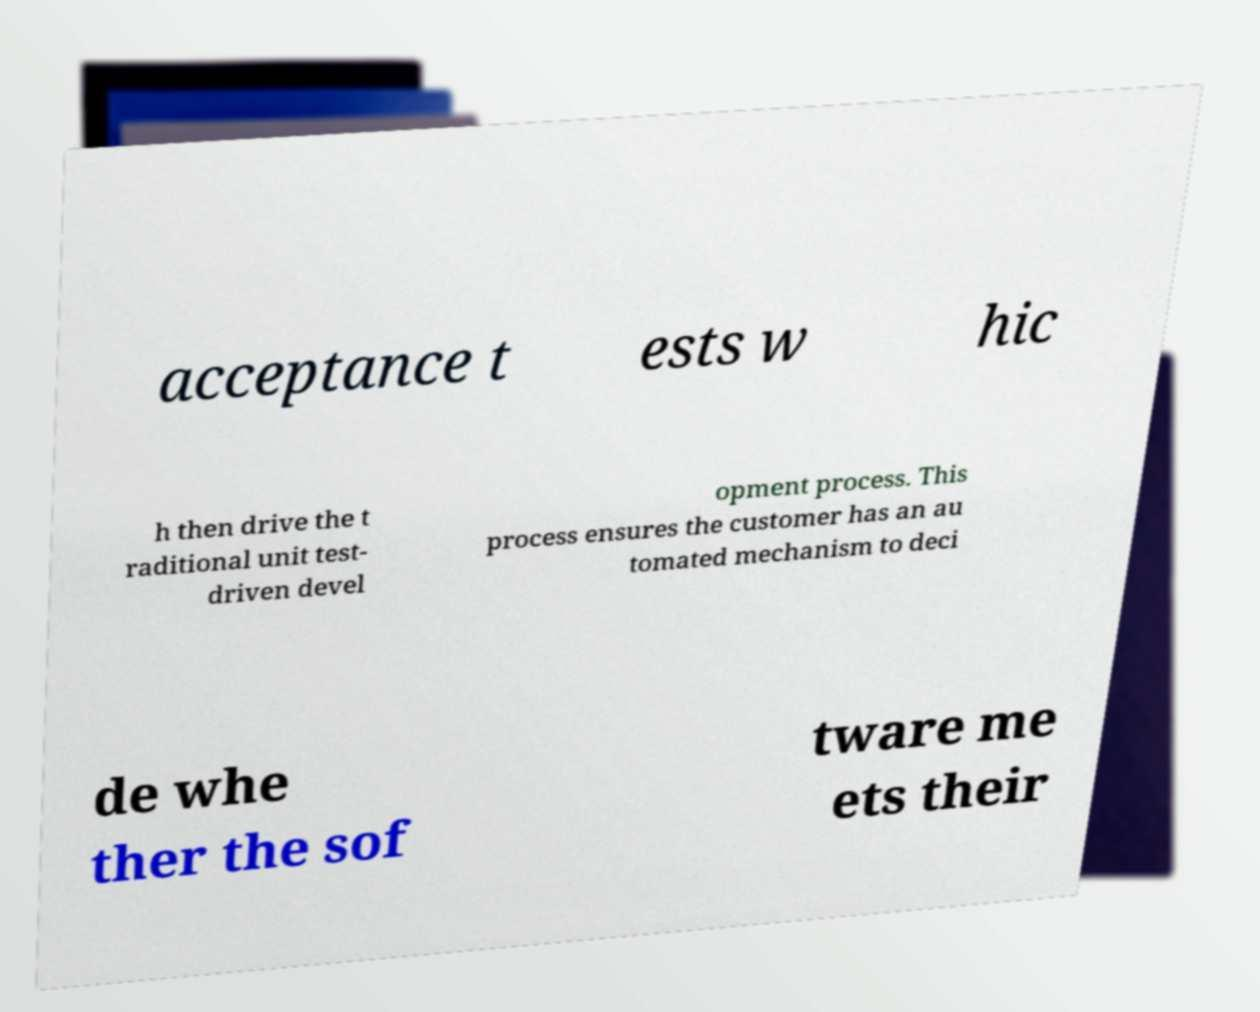Can you read and provide the text displayed in the image?This photo seems to have some interesting text. Can you extract and type it out for me? acceptance t ests w hic h then drive the t raditional unit test- driven devel opment process. This process ensures the customer has an au tomated mechanism to deci de whe ther the sof tware me ets their 